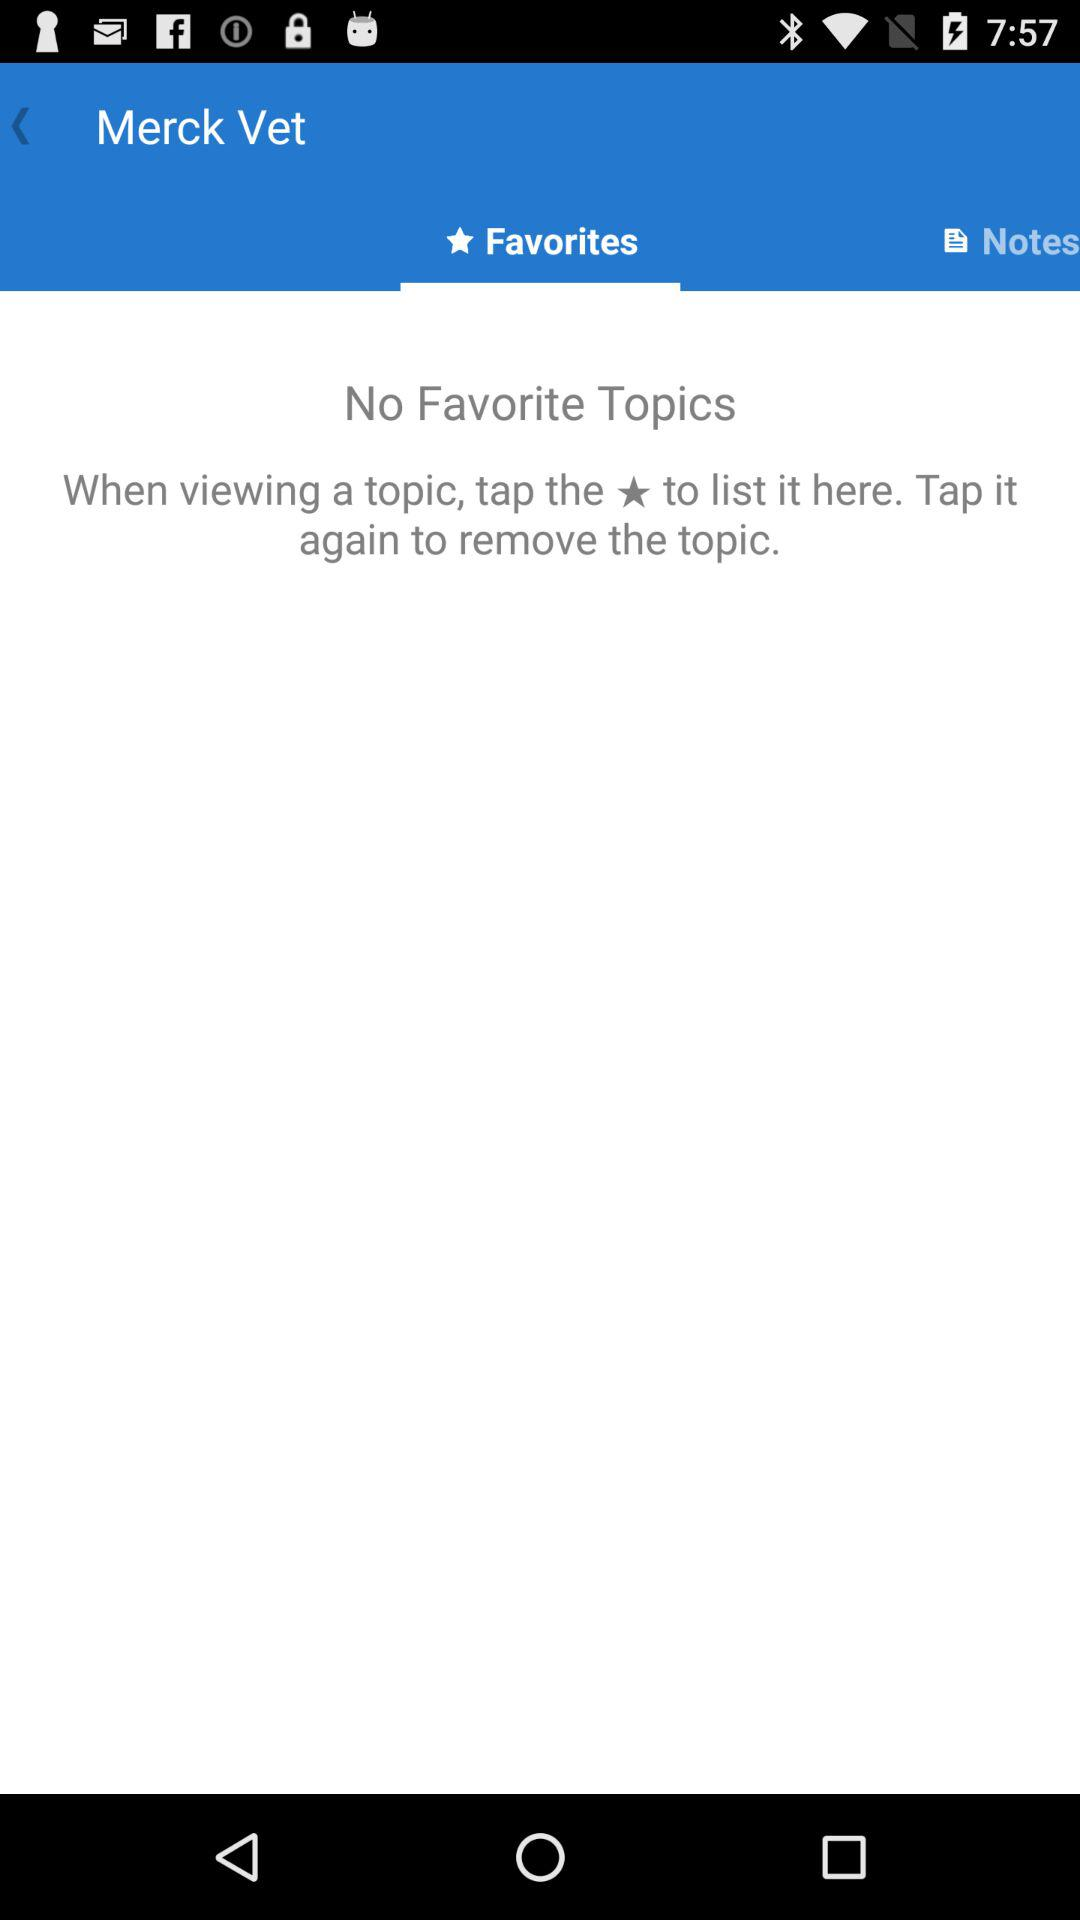What is the app name? The app name is "Merck Vet". 